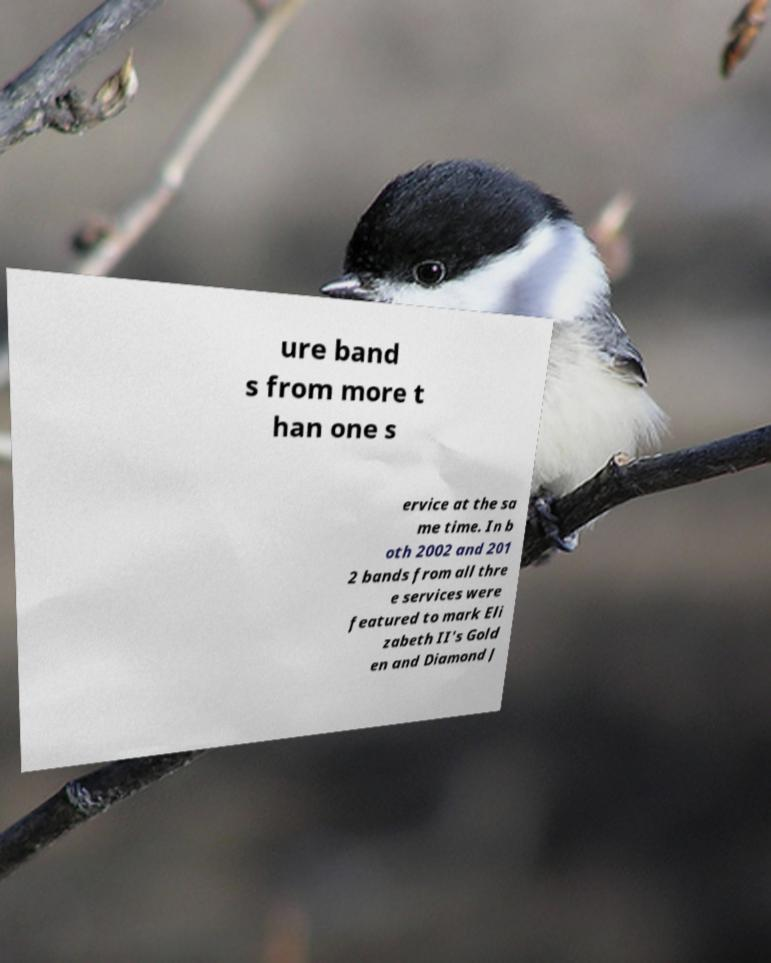Please identify and transcribe the text found in this image. ure band s from more t han one s ervice at the sa me time. In b oth 2002 and 201 2 bands from all thre e services were featured to mark Eli zabeth II's Gold en and Diamond J 